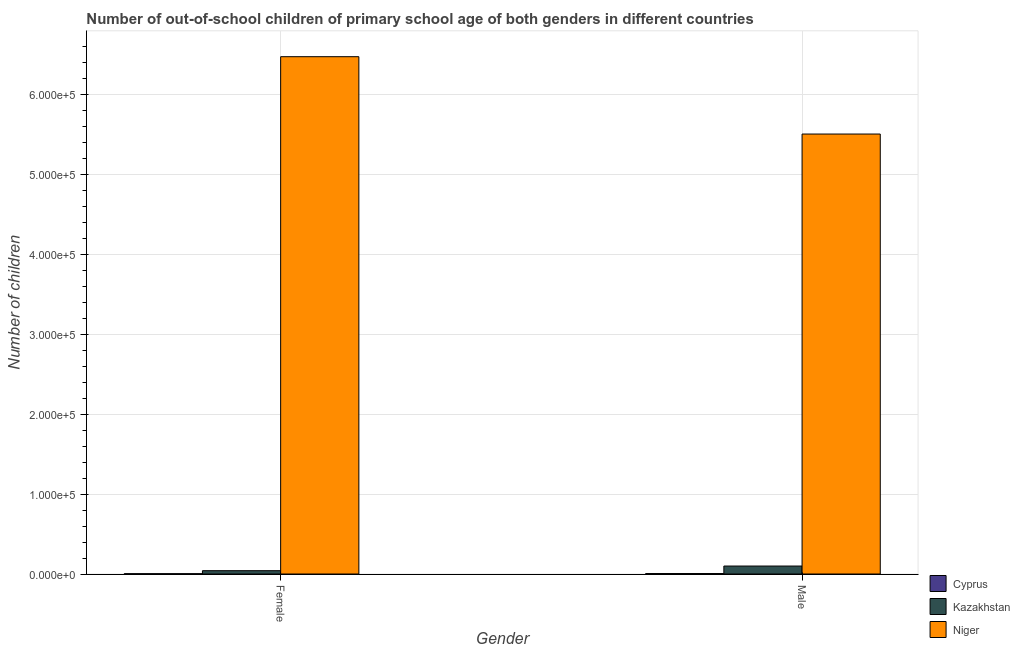How many groups of bars are there?
Your response must be concise. 2. Are the number of bars on each tick of the X-axis equal?
Offer a terse response. Yes. How many bars are there on the 1st tick from the right?
Your response must be concise. 3. What is the number of male out-of-school students in Niger?
Keep it short and to the point. 5.50e+05. Across all countries, what is the maximum number of female out-of-school students?
Provide a succinct answer. 6.47e+05. Across all countries, what is the minimum number of female out-of-school students?
Your answer should be very brief. 386. In which country was the number of male out-of-school students maximum?
Keep it short and to the point. Niger. In which country was the number of male out-of-school students minimum?
Provide a succinct answer. Cyprus. What is the total number of female out-of-school students in the graph?
Give a very brief answer. 6.52e+05. What is the difference between the number of female out-of-school students in Niger and that in Kazakhstan?
Offer a terse response. 6.43e+05. What is the difference between the number of male out-of-school students in Cyprus and the number of female out-of-school students in Kazakhstan?
Ensure brevity in your answer.  -3563. What is the average number of male out-of-school students per country?
Offer a very short reply. 1.87e+05. What is the difference between the number of male out-of-school students and number of female out-of-school students in Niger?
Provide a succinct answer. -9.67e+04. What is the ratio of the number of female out-of-school students in Niger to that in Kazakhstan?
Offer a terse response. 155.91. Is the number of male out-of-school students in Kazakhstan less than that in Cyprus?
Your answer should be very brief. No. In how many countries, is the number of male out-of-school students greater than the average number of male out-of-school students taken over all countries?
Ensure brevity in your answer.  1. What does the 2nd bar from the left in Male represents?
Your answer should be compact. Kazakhstan. What does the 2nd bar from the right in Female represents?
Make the answer very short. Kazakhstan. Are the values on the major ticks of Y-axis written in scientific E-notation?
Provide a succinct answer. Yes. Does the graph contain any zero values?
Make the answer very short. No. Does the graph contain grids?
Your response must be concise. Yes. What is the title of the graph?
Ensure brevity in your answer.  Number of out-of-school children of primary school age of both genders in different countries. Does "San Marino" appear as one of the legend labels in the graph?
Offer a terse response. No. What is the label or title of the X-axis?
Keep it short and to the point. Gender. What is the label or title of the Y-axis?
Ensure brevity in your answer.  Number of children. What is the Number of children in Cyprus in Female?
Ensure brevity in your answer.  386. What is the Number of children in Kazakhstan in Female?
Provide a succinct answer. 4150. What is the Number of children in Niger in Female?
Give a very brief answer. 6.47e+05. What is the Number of children of Cyprus in Male?
Give a very brief answer. 587. What is the Number of children in Kazakhstan in Male?
Keep it short and to the point. 9964. What is the Number of children of Niger in Male?
Provide a succinct answer. 5.50e+05. Across all Gender, what is the maximum Number of children in Cyprus?
Your answer should be compact. 587. Across all Gender, what is the maximum Number of children of Kazakhstan?
Your answer should be very brief. 9964. Across all Gender, what is the maximum Number of children in Niger?
Provide a succinct answer. 6.47e+05. Across all Gender, what is the minimum Number of children in Cyprus?
Offer a terse response. 386. Across all Gender, what is the minimum Number of children in Kazakhstan?
Make the answer very short. 4150. Across all Gender, what is the minimum Number of children of Niger?
Your response must be concise. 5.50e+05. What is the total Number of children of Cyprus in the graph?
Ensure brevity in your answer.  973. What is the total Number of children in Kazakhstan in the graph?
Offer a terse response. 1.41e+04. What is the total Number of children of Niger in the graph?
Ensure brevity in your answer.  1.20e+06. What is the difference between the Number of children of Cyprus in Female and that in Male?
Provide a succinct answer. -201. What is the difference between the Number of children in Kazakhstan in Female and that in Male?
Your answer should be compact. -5814. What is the difference between the Number of children of Niger in Female and that in Male?
Make the answer very short. 9.67e+04. What is the difference between the Number of children in Cyprus in Female and the Number of children in Kazakhstan in Male?
Provide a succinct answer. -9578. What is the difference between the Number of children in Cyprus in Female and the Number of children in Niger in Male?
Your answer should be compact. -5.50e+05. What is the difference between the Number of children in Kazakhstan in Female and the Number of children in Niger in Male?
Give a very brief answer. -5.46e+05. What is the average Number of children in Cyprus per Gender?
Your answer should be compact. 486.5. What is the average Number of children of Kazakhstan per Gender?
Your response must be concise. 7057. What is the average Number of children in Niger per Gender?
Your answer should be very brief. 5.99e+05. What is the difference between the Number of children of Cyprus and Number of children of Kazakhstan in Female?
Your response must be concise. -3764. What is the difference between the Number of children in Cyprus and Number of children in Niger in Female?
Offer a terse response. -6.47e+05. What is the difference between the Number of children of Kazakhstan and Number of children of Niger in Female?
Make the answer very short. -6.43e+05. What is the difference between the Number of children in Cyprus and Number of children in Kazakhstan in Male?
Ensure brevity in your answer.  -9377. What is the difference between the Number of children in Cyprus and Number of children in Niger in Male?
Keep it short and to the point. -5.50e+05. What is the difference between the Number of children of Kazakhstan and Number of children of Niger in Male?
Provide a succinct answer. -5.40e+05. What is the ratio of the Number of children of Cyprus in Female to that in Male?
Provide a succinct answer. 0.66. What is the ratio of the Number of children in Kazakhstan in Female to that in Male?
Your answer should be very brief. 0.42. What is the ratio of the Number of children of Niger in Female to that in Male?
Your response must be concise. 1.18. What is the difference between the highest and the second highest Number of children in Cyprus?
Provide a short and direct response. 201. What is the difference between the highest and the second highest Number of children in Kazakhstan?
Offer a very short reply. 5814. What is the difference between the highest and the second highest Number of children in Niger?
Provide a succinct answer. 9.67e+04. What is the difference between the highest and the lowest Number of children in Cyprus?
Ensure brevity in your answer.  201. What is the difference between the highest and the lowest Number of children in Kazakhstan?
Make the answer very short. 5814. What is the difference between the highest and the lowest Number of children in Niger?
Give a very brief answer. 9.67e+04. 